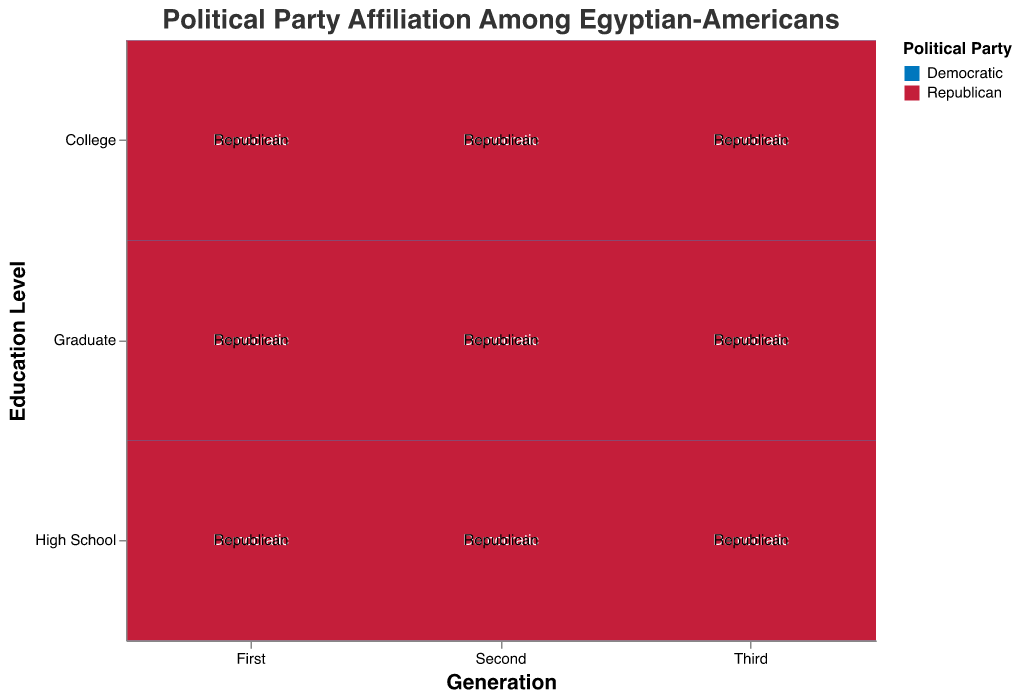What is the title of the figure? The title is displayed at the top of the mosaic plot in larger font size. It reads "Political Party Affiliation Among Egyptian-Americans".
Answer: Political Party Affiliation Among Egyptian-Americans Which generation has the highest number of Democratic affiliates with a college education? Looking at the mosaic plot, observe the height of the college blocks for Democratic affiliates across generations. The "First" generation’s college-educated Democratic affiliates have the tallest block.
Answer: First Compare the number of Republican affiliates in the "High School" education level between the "First" and "Third" generations. Which generation has more? Observe the sizes of the Republican blocks under the "High School" education level for both the "First" and "Third" generations. The "Third" generation has a larger block.
Answer: Third Among the "Second" generation, which education level shows the highest total political affiliation count (Democratic + Republican)? Sum the counts of Democratic and Republican affiliates for each education level within the "Second" generation. Graduate (105 + 60 = 165) has the highest count compared to High School (75 + 45 = 120) and College (150 + 90 = 240).
Answer: College How does the number of graduate-educated Democratic affiliates compare between the "First" and "Third" generations? Compare the sizes of the Democratic blocks under the "Graduate" education category for both the "First" and "Third" generations. The "First" generation has a larger block than the "Third" generation for graduate-educated Democratic affiliates.
Answer: First Which education level has the smallest number of Democratic affiliates in the "Third" generation? Compare the sizes of the Democratic blocks for the "Third" generation across all education levels. The "High School" level has the smallest Democratic block.
Answer: High School What is the distribution of political party affiliation among the "First" generation with a college education? Observe the "First" generation column and look at the "College" level row. The Democratic block is larger than the Republican block, indicating 180 Democratic affiliates and 45 Republican affiliates.
Answer: 180 Democratic, 45 Republican Which group in the "Second" generation has the highest number of Republican affiliates? Compare the sizes of the Republican blocks across the "High School," "College," and "Graduate" education levels. The "College" level has the tallest Republican block.
Answer: College For the "Third" generation with a college education, which political affiliation is more prevalent? Observe the "College" level within the "Third" generation and compare the sizes of the Democratic and Republican blocks. The Republican block is larger.
Answer: Republican 